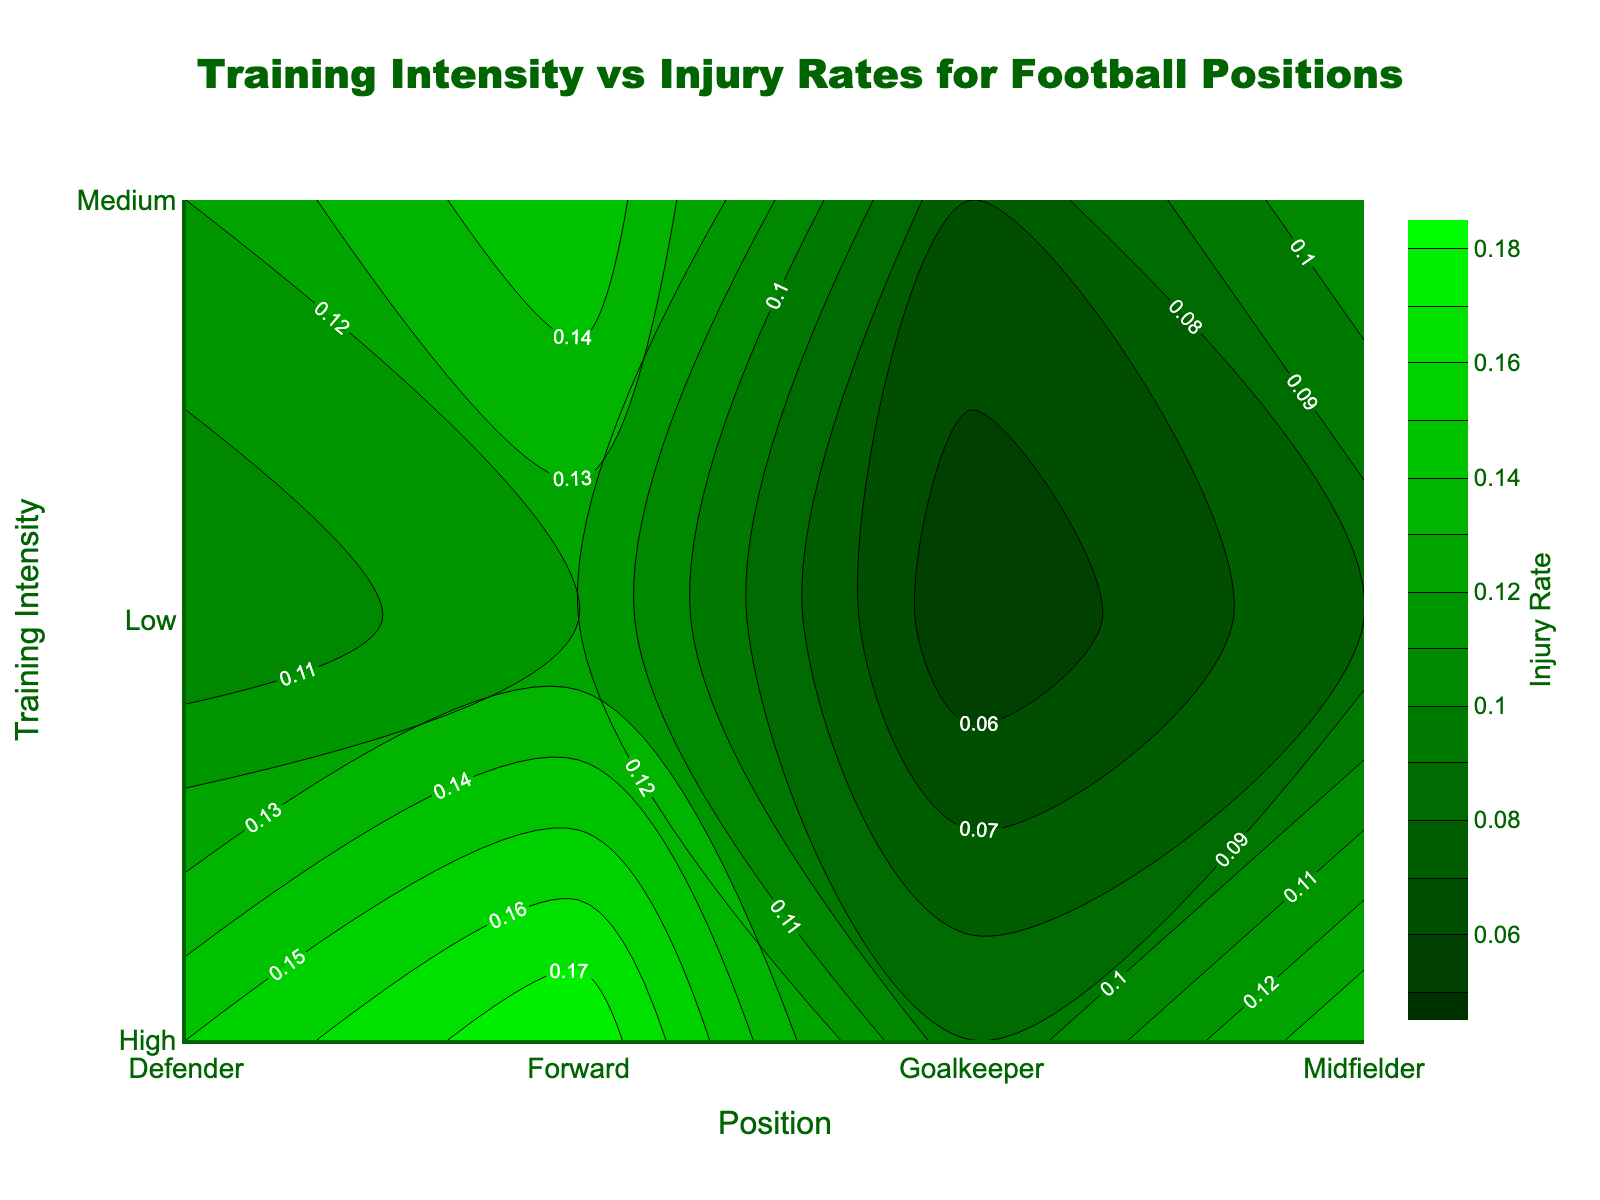What's the title of the figure? The title is typically placed at the top of the plot. It provides a brief summary of the visualized data. Here, it reads "Training Intensity vs Injury Rates for Football Positions".
Answer: Training Intensity vs Injury Rates for Football Positions How many different training intensities are shown in the plot? By looking at the y-axis labels, we see there are three: Low, Medium, and High.
Answer: 3 Which position has the highest injury rate at high training intensity? The contours and labels indicate that Forwards have the highest injury rate at high training intensity.
Answer: Forward Which position shows the lowest injury rate at low training intensity? By examining the contours and their labels at low training intensity, Goalkeepers have the lowest injury rate.
Answer: Goalkeeper What color represents the highest injury rate in the plot? Higher injury rates are represented by greener shades in the color scale. The deepest green denotes the highest injury rate.
Answer: Bright green Does the injury rate increase or decrease with higher training intensity for defenders? By observing the contour labels for Defenders moving up the y-axis from Low to High, the injury rate increases from 0.10 to 0.15.
Answer: Increase Which position has the smallest range of injury rates across all training intensities? The range can be determined by the difference between the highest and lowest injury rates for each position. Goalkeepers range from 0.05 to 0.09, which is the smallest range.
Answer: Goalkeeper Compare the injury rates between Forwards and Midfielders at medium training intensity. Who has a higher rate? Look at the contour labels for both positions at medium training intensity on the y-axis. Forwards have an injury rate of 0.15 while Midfielders have 0.11, so Forwards have a higher rate.
Answer: Forwards What's the average injury rate for Defenders across all training intensities? Sum the injury rates for Defenders (0.10 + 0.12 + 0.15) and divide by 3. It calculates to (0.10 + 0.12 + 0.15) / 3 = 0.12.
Answer: 0.12 How does the injury rate for Goalkeepers at high intensity compare to Midfielders at low intensity? From the contour labels, Goalkeepers at High intensity have an injury rate of 0.09, while Midfielders at Low have 0.08. Goalkeepers have a slightly higher rate.
Answer: Goalkeepers have a slightly higher rate 